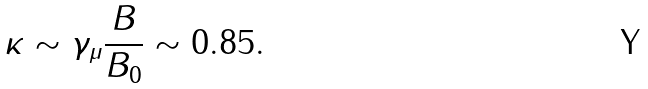<formula> <loc_0><loc_0><loc_500><loc_500>\kappa \sim \gamma _ { \mu } \frac { B } { B _ { 0 } } \sim 0 . 8 5 .</formula> 